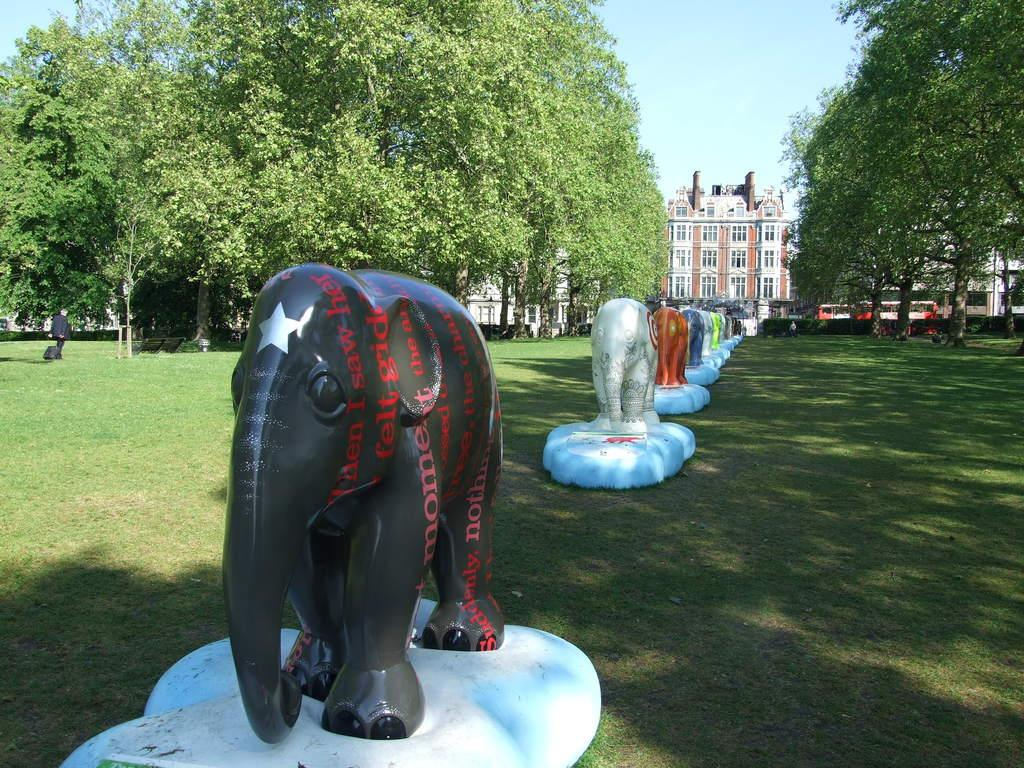What type of statues can be seen in the image? There are elephant statues in the image. How are the elephant statues arranged? The elephant statues are placed in a row. What can be seen in the background of the image? There is a building, trees, a person, and the sky visible in the background of the image. Can you tell me how the person in the image is controlling the sea? There is no sea present in the image, and therefore no control over it can be observed. 